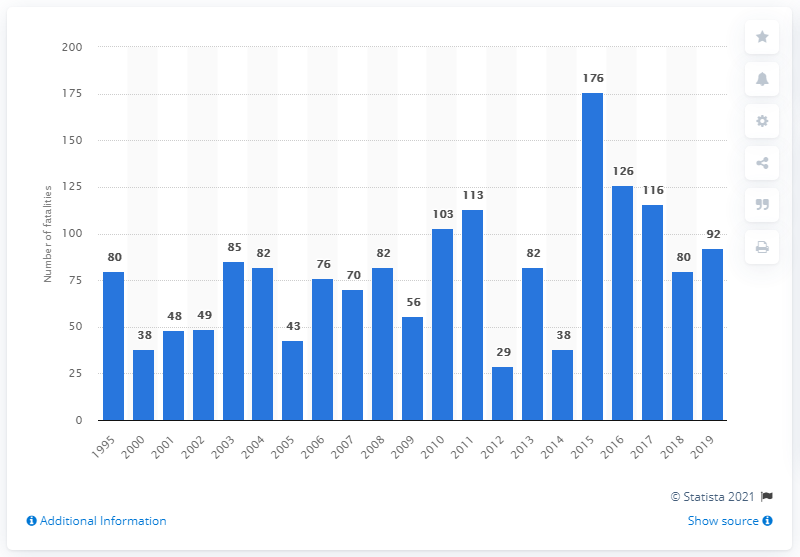Highlight a few significant elements in this photo. In 2019, a total of 92 deaths were reported due to flash floods and river floods in the United States. 